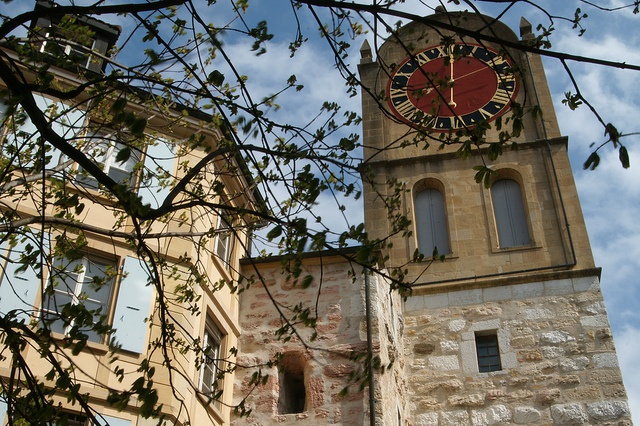Describe the objects in this image and their specific colors. I can see a clock in gray, maroon, black, and tan tones in this image. 